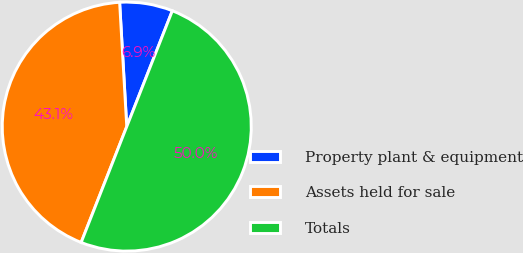Convert chart to OTSL. <chart><loc_0><loc_0><loc_500><loc_500><pie_chart><fcel>Property plant & equipment<fcel>Assets held for sale<fcel>Totals<nl><fcel>6.88%<fcel>43.12%<fcel>50.0%<nl></chart> 